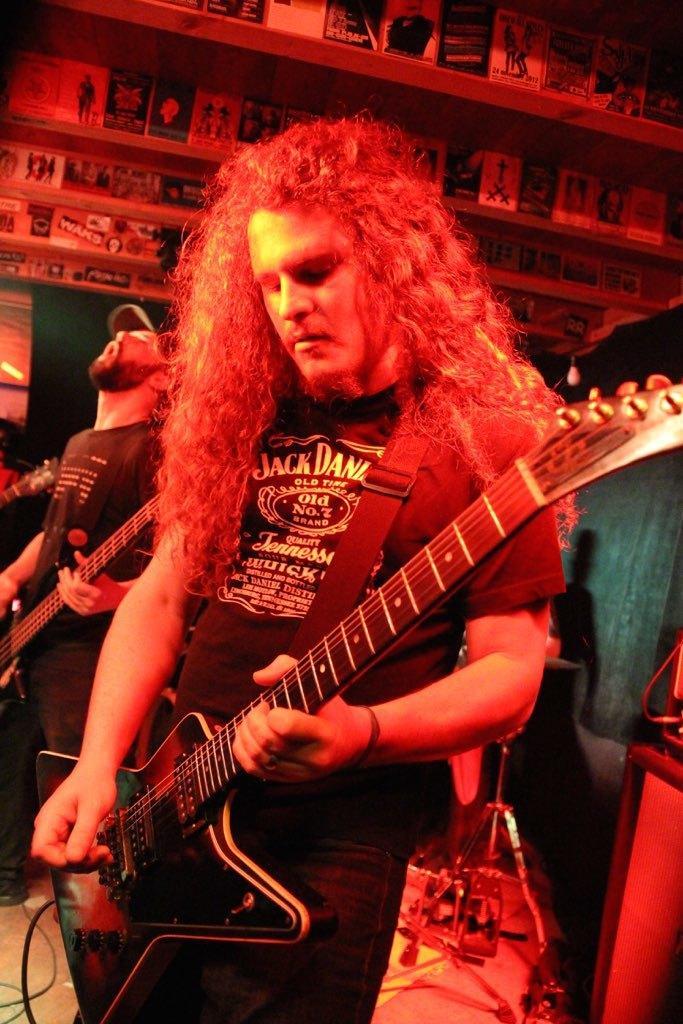Describe this image in one or two sentences. In this picture we can see men standing and playing guitar. On the background we can see posters. 